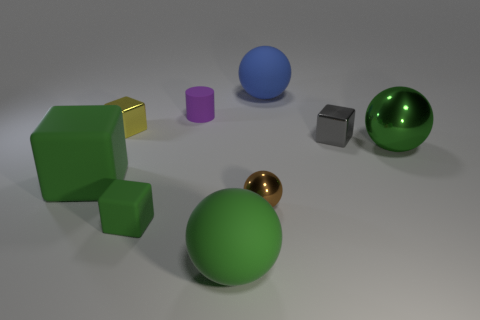Is the shape of the brown shiny object the same as the big metallic object?
Provide a succinct answer. Yes. There is a green object that is made of the same material as the gray thing; what size is it?
Offer a terse response. Large. What number of purple things are big rubber things or small cylinders?
Your answer should be compact. 1. How many large matte objects are behind the green matte thing that is behind the small green rubber cube?
Ensure brevity in your answer.  1. Is the number of tiny metallic balls that are on the right side of the purple matte cylinder greater than the number of cylinders that are in front of the small yellow shiny thing?
Your answer should be very brief. Yes. What is the material of the tiny purple cylinder?
Ensure brevity in your answer.  Rubber. Are there any blue rubber spheres of the same size as the brown ball?
Make the answer very short. No. There is a green cube that is the same size as the blue ball; what is its material?
Offer a very short reply. Rubber. What number of tiny brown balls are there?
Your answer should be compact. 1. What size is the metallic sphere to the right of the big blue thing?
Provide a short and direct response. Large. 